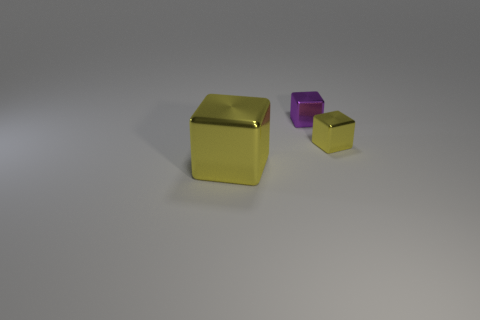Add 1 gray metal balls. How many objects exist? 4 Subtract all cyan cylinders. How many purple blocks are left? 1 Subtract all cubes. Subtract all small blue things. How many objects are left? 0 Add 1 small purple things. How many small purple things are left? 2 Add 3 yellow metallic cubes. How many yellow metallic cubes exist? 5 Subtract all purple cubes. How many cubes are left? 2 Subtract all small yellow metal blocks. How many blocks are left? 2 Subtract 0 red cylinders. How many objects are left? 3 Subtract 3 cubes. How many cubes are left? 0 Subtract all red cubes. Subtract all brown balls. How many cubes are left? 3 